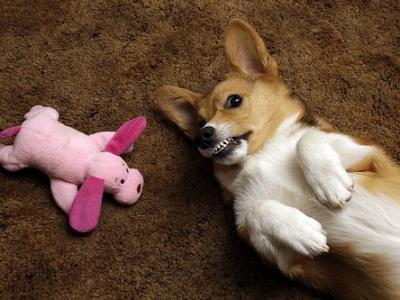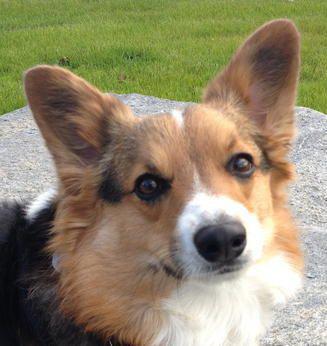The first image is the image on the left, the second image is the image on the right. Given the left and right images, does the statement "The dogs are all either standing or sitting while looking at the camera." hold true? Answer yes or no. No. The first image is the image on the left, the second image is the image on the right. For the images shown, is this caption "One dog has his mouth shut." true? Answer yes or no. Yes. 